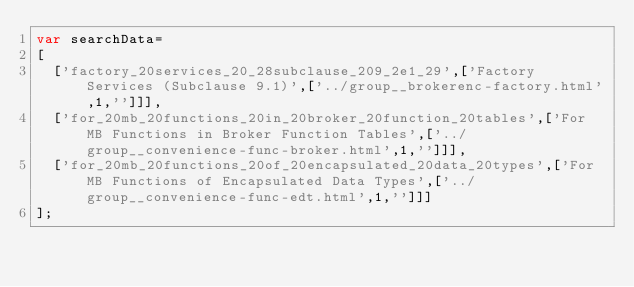Convert code to text. <code><loc_0><loc_0><loc_500><loc_500><_JavaScript_>var searchData=
[
  ['factory_20services_20_28subclause_209_2e1_29',['Factory Services (Subclause 9.1)',['../group__brokerenc-factory.html',1,'']]],
  ['for_20mb_20functions_20in_20broker_20function_20tables',['For MB Functions in Broker Function Tables',['../group__convenience-func-broker.html',1,'']]],
  ['for_20mb_20functions_20of_20encapsulated_20data_20types',['For MB Functions of Encapsulated Data Types',['../group__convenience-func-edt.html',1,'']]]
];
</code> 